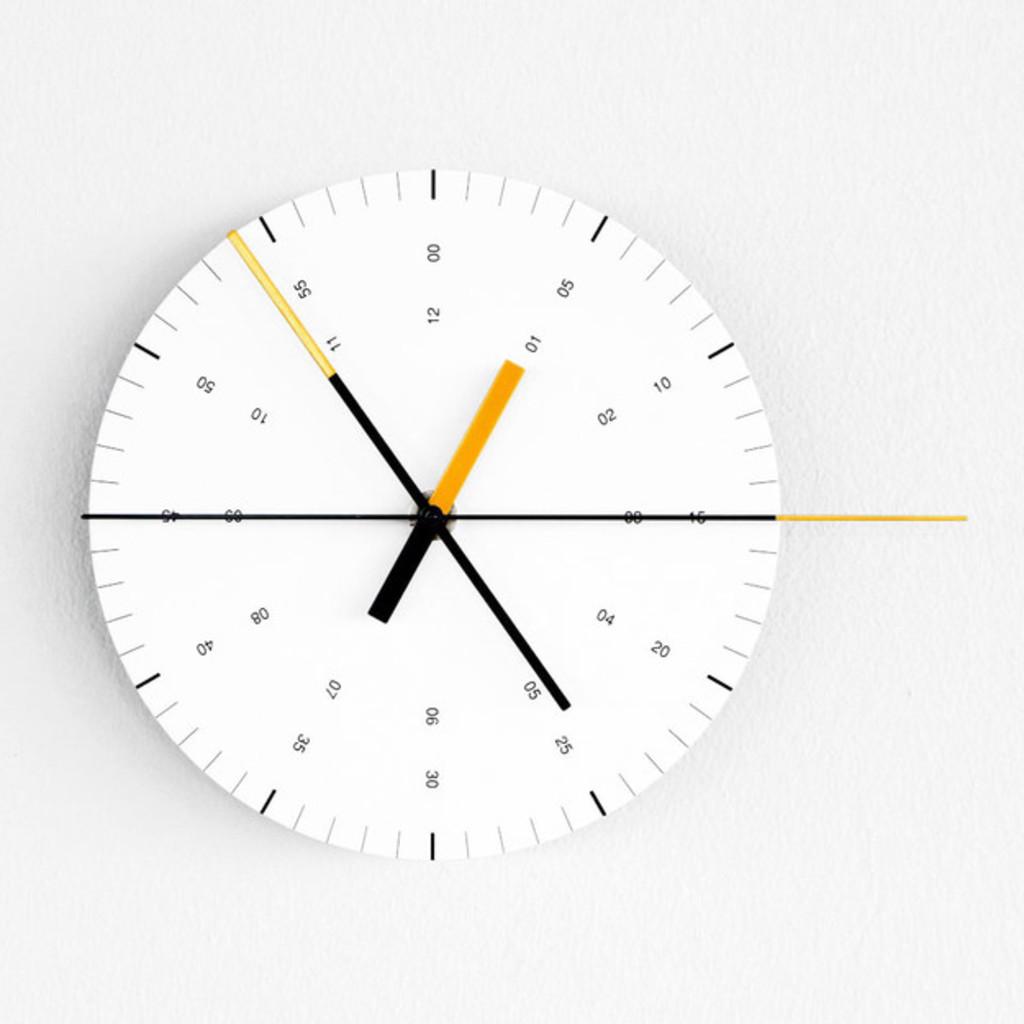What's the highest number shown on the clock?
Provide a succinct answer. 55. What time is it?
Keep it short and to the point. 12:54. 